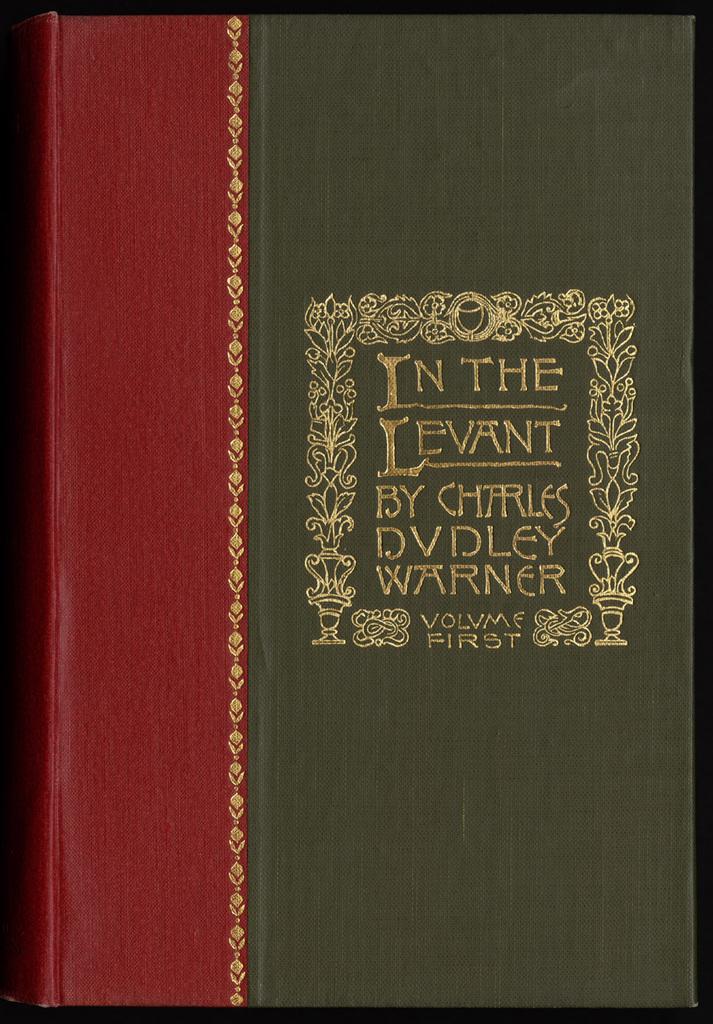What volume of the series is this?
Ensure brevity in your answer.  First. Who wrote this?
Offer a very short reply. Charles dudley warner. 